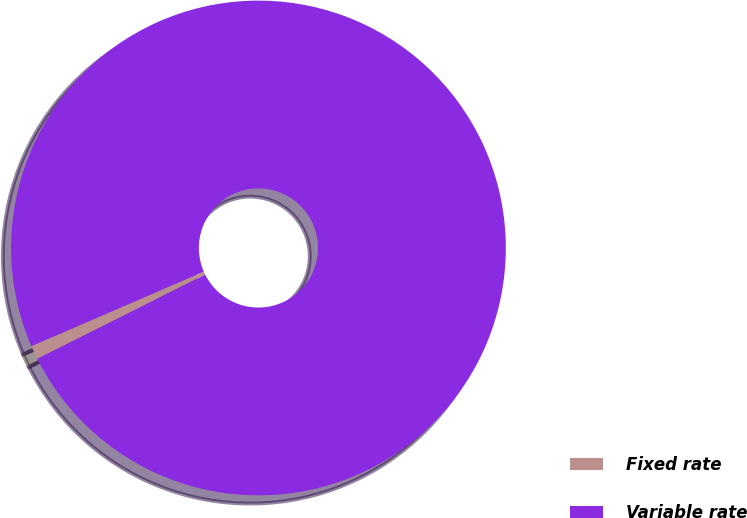Convert chart. <chart><loc_0><loc_0><loc_500><loc_500><pie_chart><fcel>Fixed rate<fcel>Variable rate<nl><fcel>0.89%<fcel>99.11%<nl></chart> 